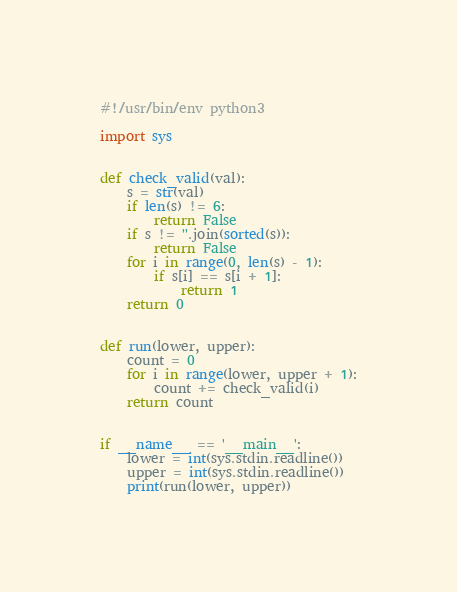Convert code to text. <code><loc_0><loc_0><loc_500><loc_500><_Python_>#!/usr/bin/env python3

import sys


def check_valid(val):
    s = str(val)
    if len(s) != 6:
        return False
    if s != ''.join(sorted(s)):
        return False
    for i in range(0, len(s) - 1):
        if s[i] == s[i + 1]:
            return 1
    return 0


def run(lower, upper):
    count = 0
    for i in range(lower, upper + 1):
        count += check_valid(i)
    return count


if __name__ == '__main__':
    lower = int(sys.stdin.readline())
    upper = int(sys.stdin.readline())
    print(run(lower, upper))

</code> 